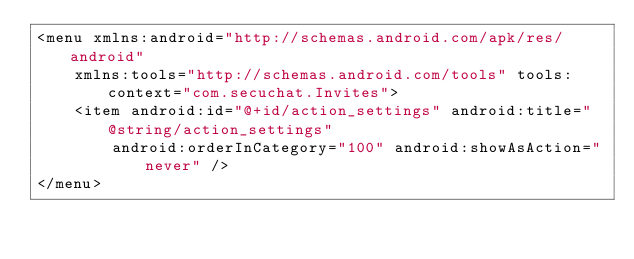<code> <loc_0><loc_0><loc_500><loc_500><_XML_><menu xmlns:android="http://schemas.android.com/apk/res/android"
    xmlns:tools="http://schemas.android.com/tools" tools:context="com.secuchat.Invites">
    <item android:id="@+id/action_settings" android:title="@string/action_settings"
        android:orderInCategory="100" android:showAsAction="never" />
</menu>
</code> 